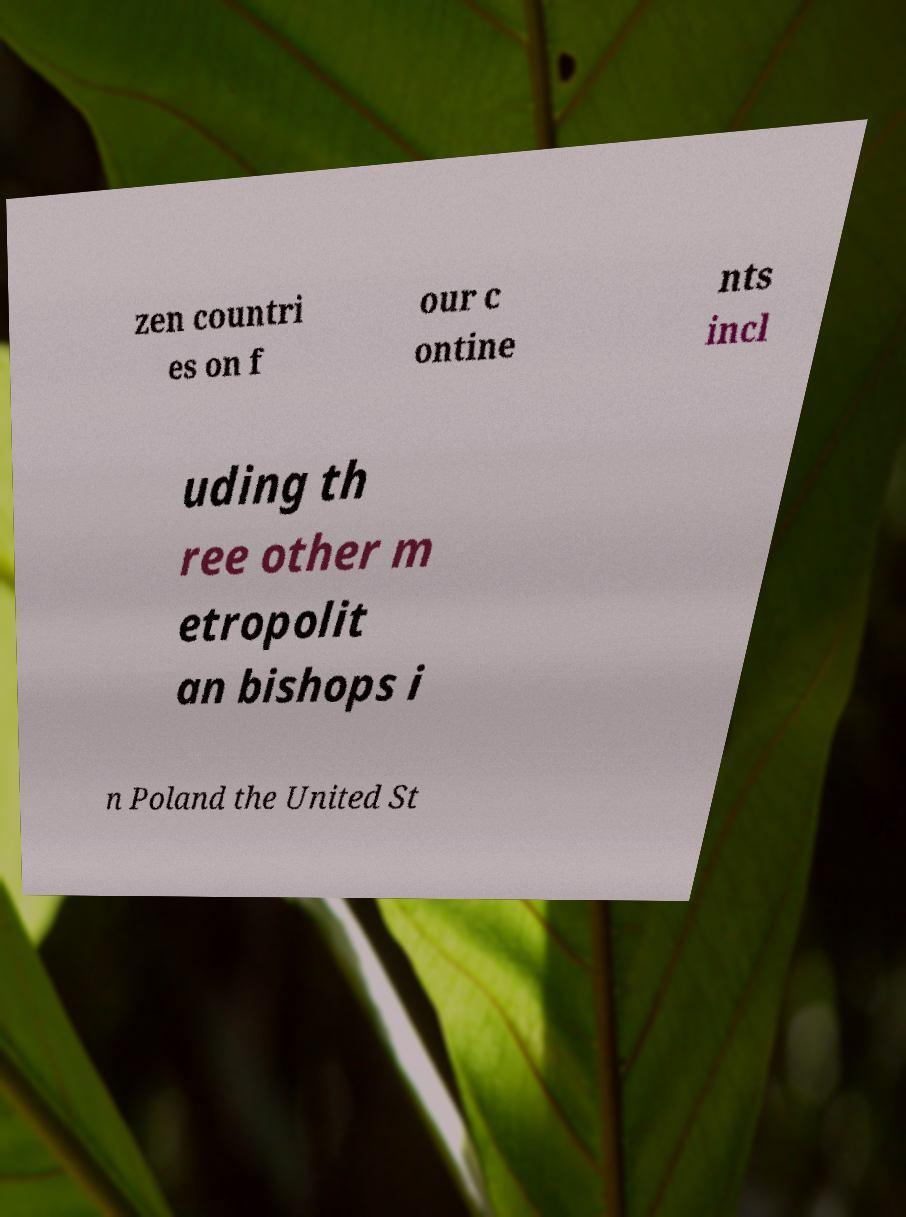Can you read and provide the text displayed in the image?This photo seems to have some interesting text. Can you extract and type it out for me? zen countri es on f our c ontine nts incl uding th ree other m etropolit an bishops i n Poland the United St 